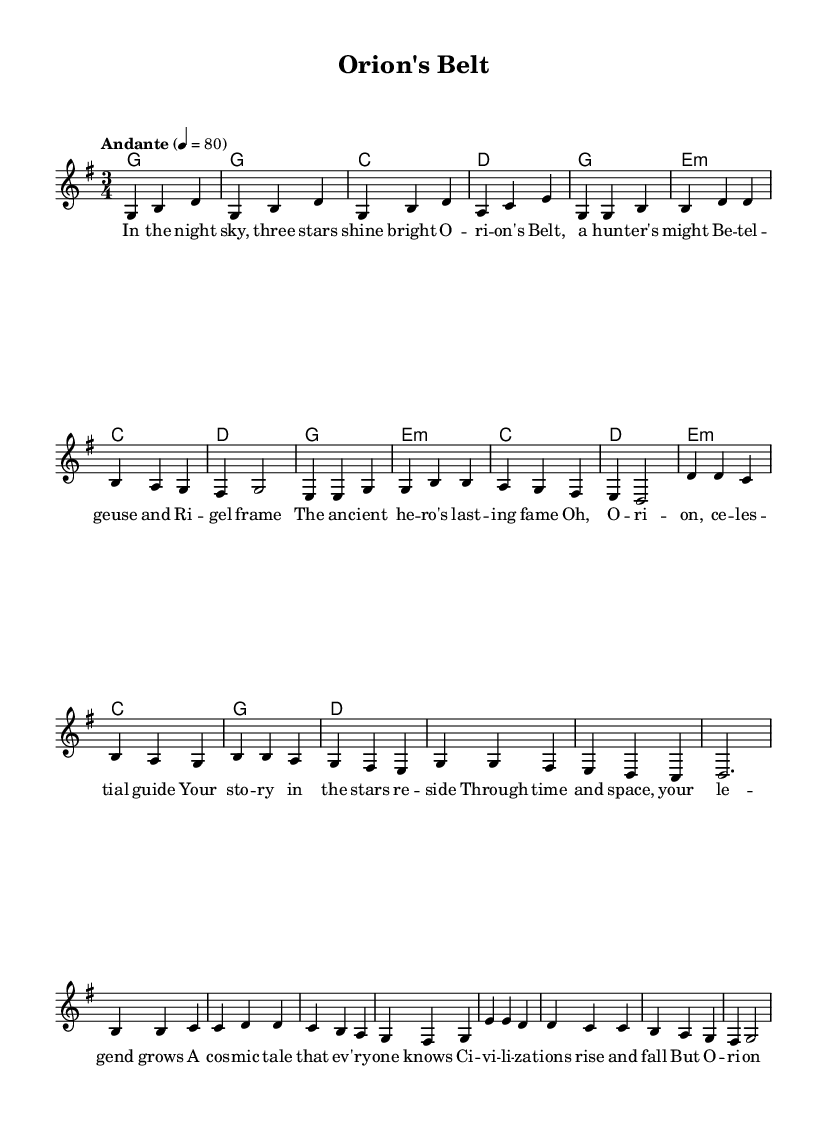What is the key signature of this music? The key signature is G major, which is indicated by one sharp (F#) in the key signature box at the beginning of the sheet music.
Answer: G major What is the time signature of this music? The time signature is 3/4, which is clearly displayed right next to the key signature at the beginning of the sheet music, indicating three beats per measure.
Answer: 3/4 What is the tempo marking for this piece? The tempo marking is "Andante" and it indicates a moderate pace, which is shown above the staff in the tempo directive and suggests a speed of 80 beats per minute.
Answer: Andante How many measures are in the first verse? By counting the measures from the start of the verse section until the end, there are a total of 8 measures in the first verse.
Answer: 8 What musical form does this ballad follow? This ballad follows a verse-chorus structure, as indicated by the sections labeled "Verse 1," "Chorus," and "Bridge," showcasing the typical Folk music form.
Answer: Verse-Chorus What is the name of the piece indicated in the header? The piece is titled "Orion's Belt," which is stated in the header section of the sheet music.
Answer: Orion's Belt How many chords are used in the bridge section? The bridge section utilizes 4 unique chords as indicated in the harmonies line for that segment, where each chord is specified in its own measure.
Answer: 4 